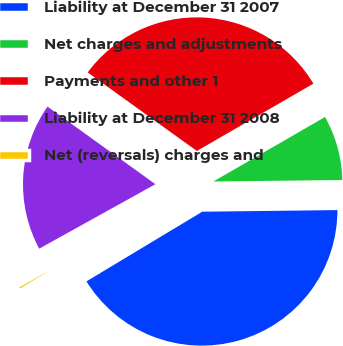Convert chart. <chart><loc_0><loc_0><loc_500><loc_500><pie_chart><fcel>Liability at December 31 2007<fcel>Net charges and adjustments<fcel>Payments and other 1<fcel>Liability at December 31 2008<fcel>Net (reversals) charges and<nl><fcel>41.57%<fcel>8.15%<fcel>31.74%<fcel>17.98%<fcel>0.56%<nl></chart> 